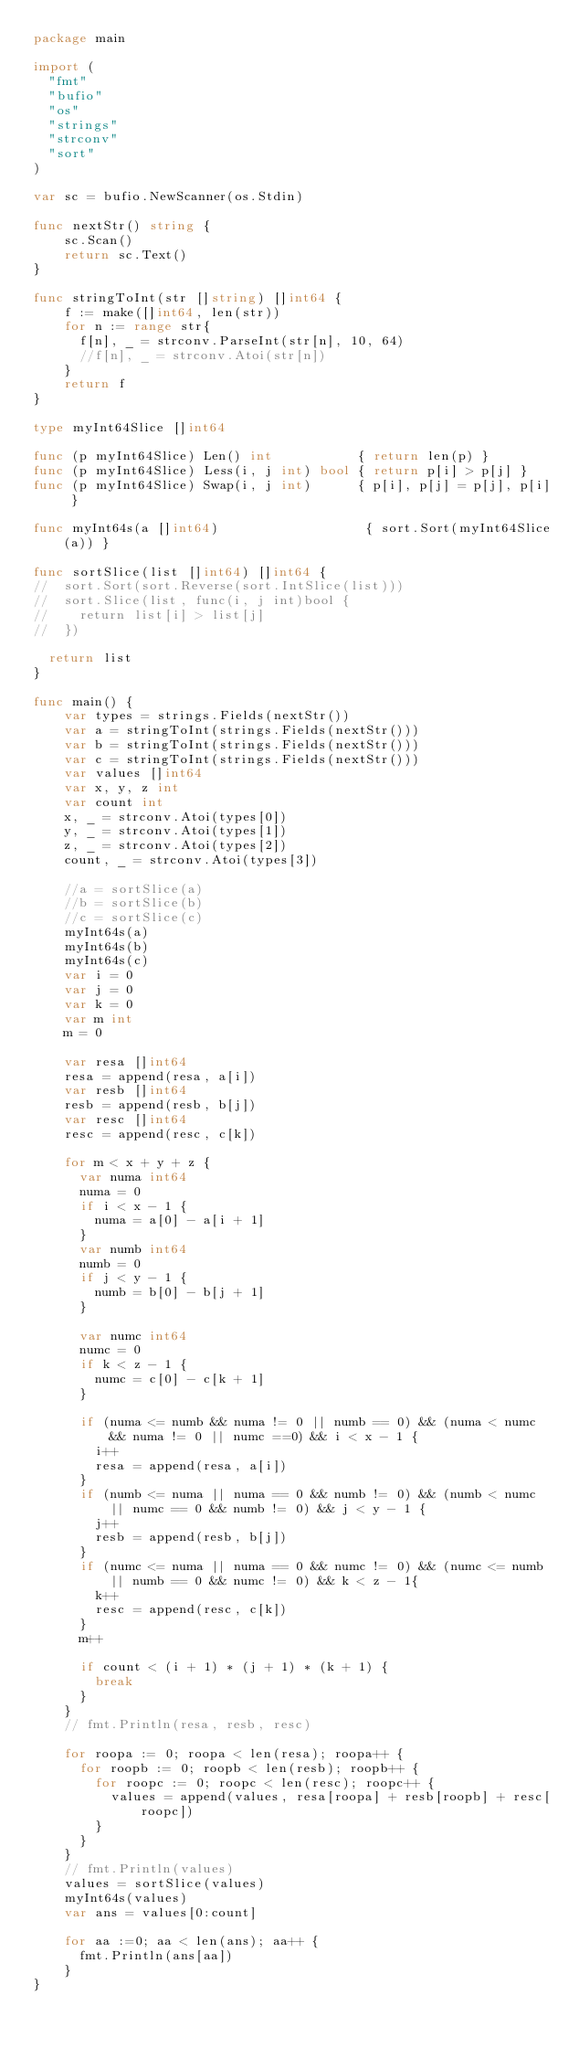<code> <loc_0><loc_0><loc_500><loc_500><_Go_>package main

import (
  "fmt"
  "bufio"
  "os"
  "strings"
  "strconv"
  "sort"
)

var sc = bufio.NewScanner(os.Stdin)

func nextStr() string {
    sc.Scan()
    return sc.Text()
}

func stringToInt(str []string) []int64 {
    f := make([]int64, len(str))
    for n := range str{
      f[n], _ = strconv.ParseInt(str[n], 10, 64)
      //f[n], _ = strconv.Atoi(str[n])
    }
    return f
}

type myInt64Slice []int64

func (p myInt64Slice) Len() int           { return len(p) }
func (p myInt64Slice) Less(i, j int) bool { return p[i] > p[j] }
func (p myInt64Slice) Swap(i, j int)      { p[i], p[j] = p[j], p[i] }

func myInt64s(a []int64)                   { sort.Sort(myInt64Slice(a)) }

func sortSlice(list []int64) []int64 {
//  sort.Sort(sort.Reverse(sort.IntSlice(list)))
//  sort.Slice(list, func(i, j int)bool {
//    return list[i] > list[j]
//  })

  return list
}

func main() {
    var types = strings.Fields(nextStr())
    var a = stringToInt(strings.Fields(nextStr()))
    var b = stringToInt(strings.Fields(nextStr()))
    var c = stringToInt(strings.Fields(nextStr()))
    var values []int64
    var x, y, z int
    var count int
    x, _ = strconv.Atoi(types[0])
    y, _ = strconv.Atoi(types[1])
    z, _ = strconv.Atoi(types[2])
    count, _ = strconv.Atoi(types[3])

    //a = sortSlice(a)
    //b = sortSlice(b)
    //c = sortSlice(c)
    myInt64s(a)
    myInt64s(b)
    myInt64s(c)
    var i = 0
    var j = 0
    var k = 0
    var m int
    m = 0

    var resa []int64
    resa = append(resa, a[i])
    var resb []int64
    resb = append(resb, b[j])
    var resc []int64
    resc = append(resc, c[k])

    for m < x + y + z {
      var numa int64
      numa = 0
      if i < x - 1 {
        numa = a[0] - a[i + 1]
      }
      var numb int64
      numb = 0
      if j < y - 1 {
        numb = b[0] - b[j + 1]
      }

      var numc int64
      numc = 0
      if k < z - 1 {
        numc = c[0] - c[k + 1]
      }

      if (numa <= numb && numa != 0 || numb == 0) && (numa < numc && numa != 0 || numc ==0) && i < x - 1 {
        i++
        resa = append(resa, a[i])
      }
      if (numb <= numa || numa == 0 && numb != 0) && (numb < numc || numc == 0 && numb != 0) && j < y - 1 {
        j++
        resb = append(resb, b[j])
      }
      if (numc <= numa || numa == 0 && numc != 0) && (numc <= numb || numb == 0 && numc != 0) && k < z - 1{
        k++
        resc = append(resc, c[k])
      }
      m++

      if count < (i + 1) * (j + 1) * (k + 1) {
        break
      }
    }
    // fmt.Println(resa, resb, resc)

    for roopa := 0; roopa < len(resa); roopa++ {
      for roopb := 0; roopb < len(resb); roopb++ {
        for roopc := 0; roopc < len(resc); roopc++ {
          values = append(values, resa[roopa] + resb[roopb] + resc[roopc])
        }
      }
    }
    // fmt.Println(values)
    values = sortSlice(values)
    myInt64s(values)
    var ans = values[0:count]

    for aa :=0; aa < len(ans); aa++ {
      fmt.Println(ans[aa])
    }
}

</code> 